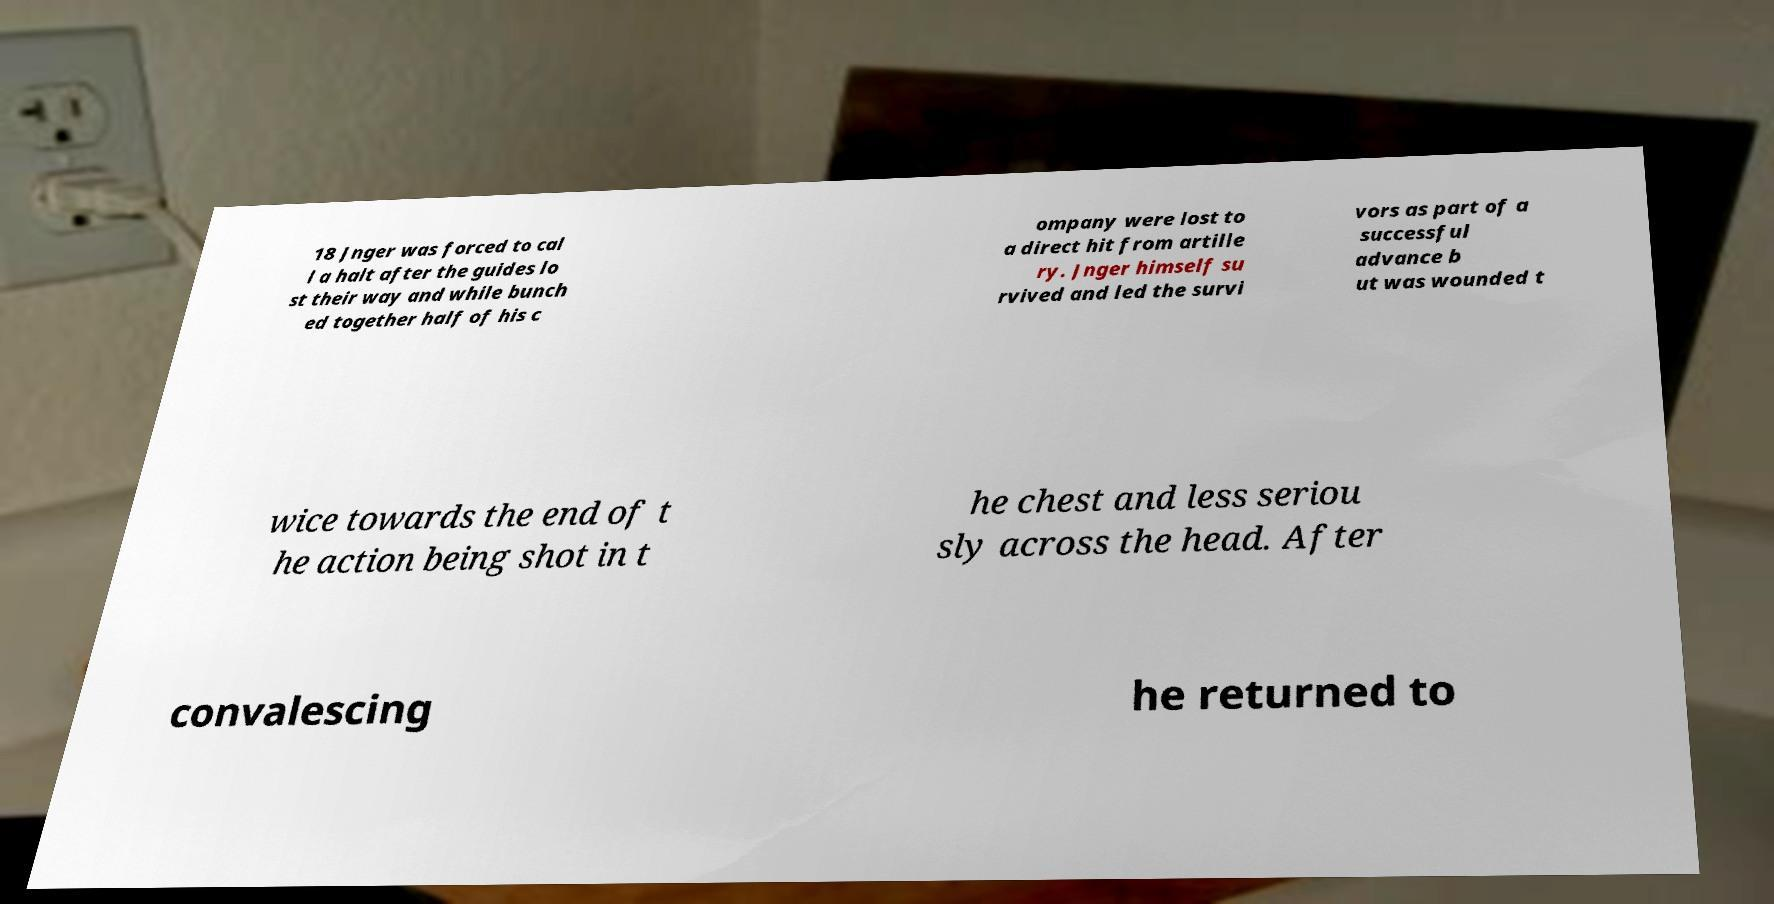Please read and relay the text visible in this image. What does it say? 18 Jnger was forced to cal l a halt after the guides lo st their way and while bunch ed together half of his c ompany were lost to a direct hit from artille ry. Jnger himself su rvived and led the survi vors as part of a successful advance b ut was wounded t wice towards the end of t he action being shot in t he chest and less seriou sly across the head. After convalescing he returned to 